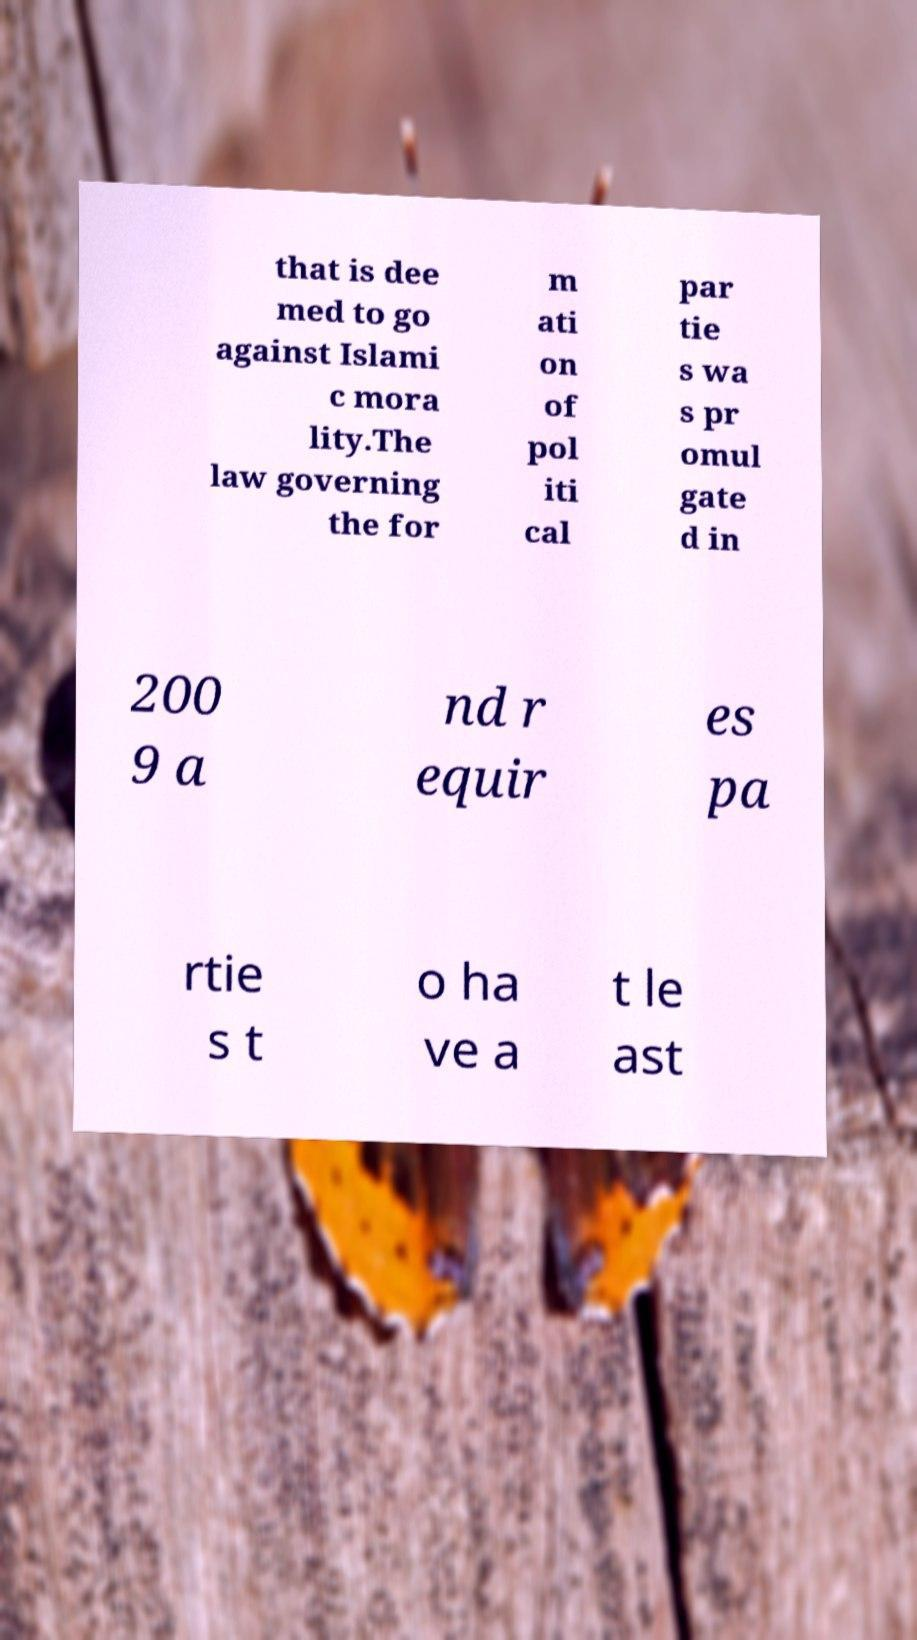There's text embedded in this image that I need extracted. Can you transcribe it verbatim? that is dee med to go against Islami c mora lity.The law governing the for m ati on of pol iti cal par tie s wa s pr omul gate d in 200 9 a nd r equir es pa rtie s t o ha ve a t le ast 